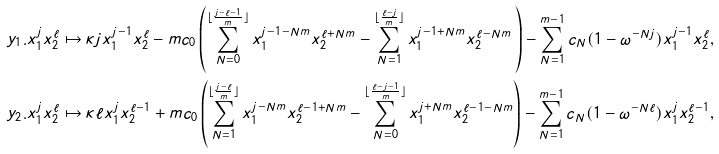<formula> <loc_0><loc_0><loc_500><loc_500>y _ { 1 } . x _ { 1 } ^ { j } x _ { 2 } ^ { \ell } & \mapsto \kappa j x _ { 1 } ^ { j - 1 } x _ { 2 } ^ { \ell } - m { c } _ { 0 } \left ( \sum _ { N = 0 } ^ { \lfloor { \frac { j - \ell - 1 } { m } } \rfloor } x _ { 1 } ^ { j - 1 - N m } x _ { 2 } ^ { \ell + N m } - \sum _ { N = 1 } ^ { \lfloor { \frac { \ell - j } { m } } \rfloor } x _ { 1 } ^ { j - 1 + N m } x _ { 2 } ^ { \ell - N m } \, \right ) - \sum _ { N = 1 } ^ { m - 1 } { c } _ { N } ( 1 - \omega ^ { - N j } ) x _ { 1 } ^ { j - 1 } x _ { 2 } ^ { \ell } , \\ y _ { 2 } . x _ { 1 } ^ { j } x _ { 2 } ^ { \ell } & \mapsto \kappa \ell x _ { 1 } ^ { j } x _ { 2 } ^ { \ell - 1 } + m { c } _ { 0 } \left ( \sum _ { N = 1 } ^ { \lfloor { \frac { j - \ell } { m } } \rfloor } x _ { 1 } ^ { j - N m } x _ { 2 } ^ { \ell - 1 + N m } - \sum _ { N = 0 } ^ { \lfloor { \frac { \ell - j - 1 } { m } } \rfloor } x _ { 1 } ^ { j + N m } x _ { 2 } ^ { \ell - 1 - N m } \right ) - \sum _ { N = 1 } ^ { m - 1 } { c } _ { N } ( 1 - \omega ^ { - N \ell } ) x _ { 1 } ^ { j } x _ { 2 } ^ { \ell - 1 } ,</formula> 